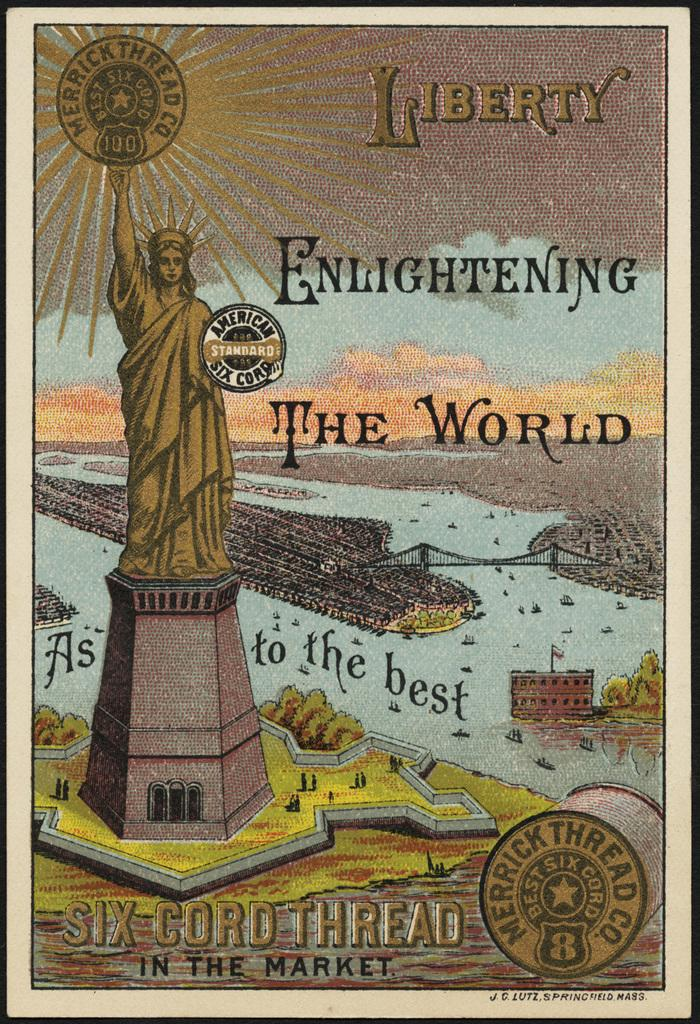What is the main subject in the center of the image? There is a poster in the center of the image. What can be seen on the left side of the image? There is a statue on the left side of the image. What color is the tongue of the flower in the image? There is no flower or tongue present in the image. 